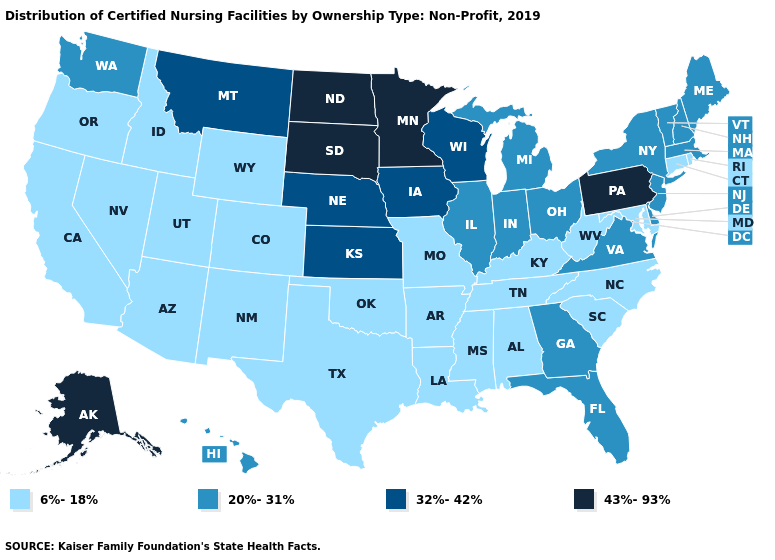What is the highest value in the South ?
Write a very short answer. 20%-31%. Which states have the lowest value in the South?
Write a very short answer. Alabama, Arkansas, Kentucky, Louisiana, Maryland, Mississippi, North Carolina, Oklahoma, South Carolina, Tennessee, Texas, West Virginia. Among the states that border North Carolina , which have the lowest value?
Quick response, please. South Carolina, Tennessee. Among the states that border Massachusetts , which have the highest value?
Quick response, please. New Hampshire, New York, Vermont. Does Alaska have the highest value in the USA?
Quick response, please. Yes. What is the value of Montana?
Quick response, please. 32%-42%. Name the states that have a value in the range 32%-42%?
Answer briefly. Iowa, Kansas, Montana, Nebraska, Wisconsin. What is the lowest value in the MidWest?
Concise answer only. 6%-18%. How many symbols are there in the legend?
Keep it brief. 4. What is the value of Illinois?
Be succinct. 20%-31%. How many symbols are there in the legend?
Be succinct. 4. Does New Mexico have the highest value in the West?
Be succinct. No. Name the states that have a value in the range 6%-18%?
Short answer required. Alabama, Arizona, Arkansas, California, Colorado, Connecticut, Idaho, Kentucky, Louisiana, Maryland, Mississippi, Missouri, Nevada, New Mexico, North Carolina, Oklahoma, Oregon, Rhode Island, South Carolina, Tennessee, Texas, Utah, West Virginia, Wyoming. What is the value of Kansas?
Be succinct. 32%-42%. Which states have the highest value in the USA?
Be succinct. Alaska, Minnesota, North Dakota, Pennsylvania, South Dakota. 